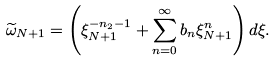Convert formula to latex. <formula><loc_0><loc_0><loc_500><loc_500>\widetilde { \omega } _ { N + 1 } = \left ( \xi ^ { - n _ { 2 } - 1 } _ { N + 1 } + \sum _ { n = 0 } ^ { \infty } b _ { n } \xi ^ { n } _ { N + 1 } \right ) d \xi .</formula> 